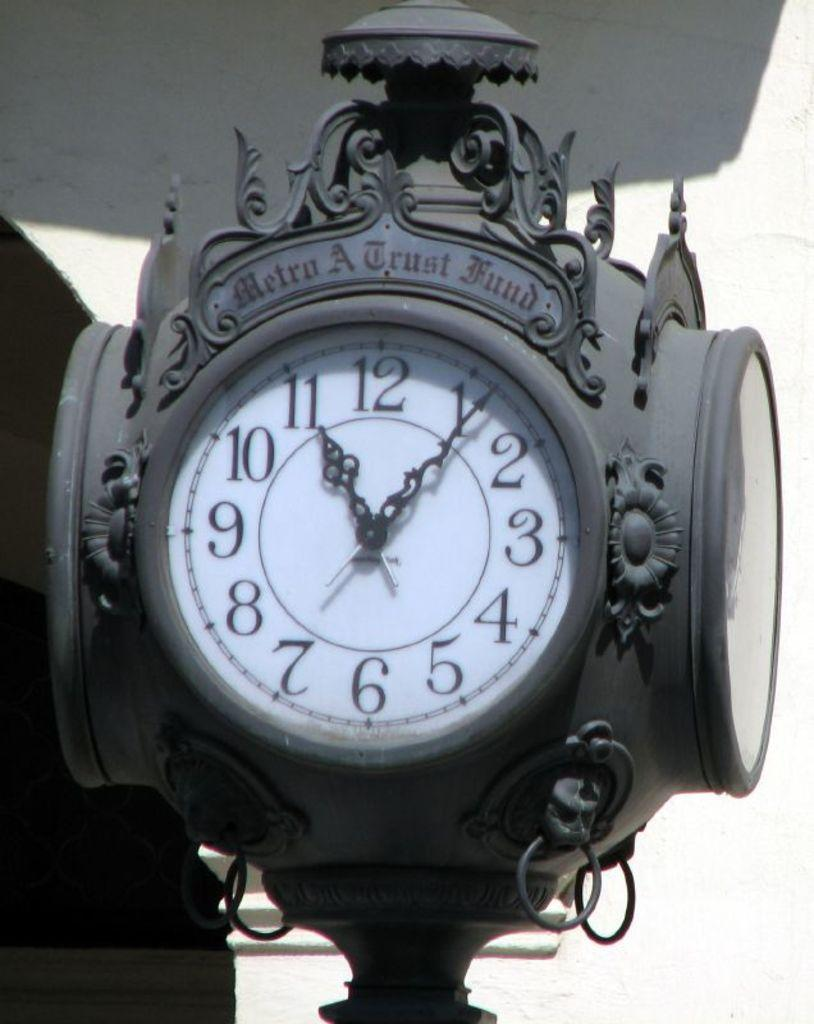<image>
Present a compact description of the photo's key features. Old clock with the words Metro A Trust Fund on the top. 